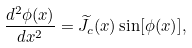Convert formula to latex. <formula><loc_0><loc_0><loc_500><loc_500>\frac { d ^ { 2 } { \phi } ( x ) } { d x ^ { 2 } } = \widetilde { J } _ { c } ( x ) \sin [ { \phi ( x ) } ] ,</formula> 